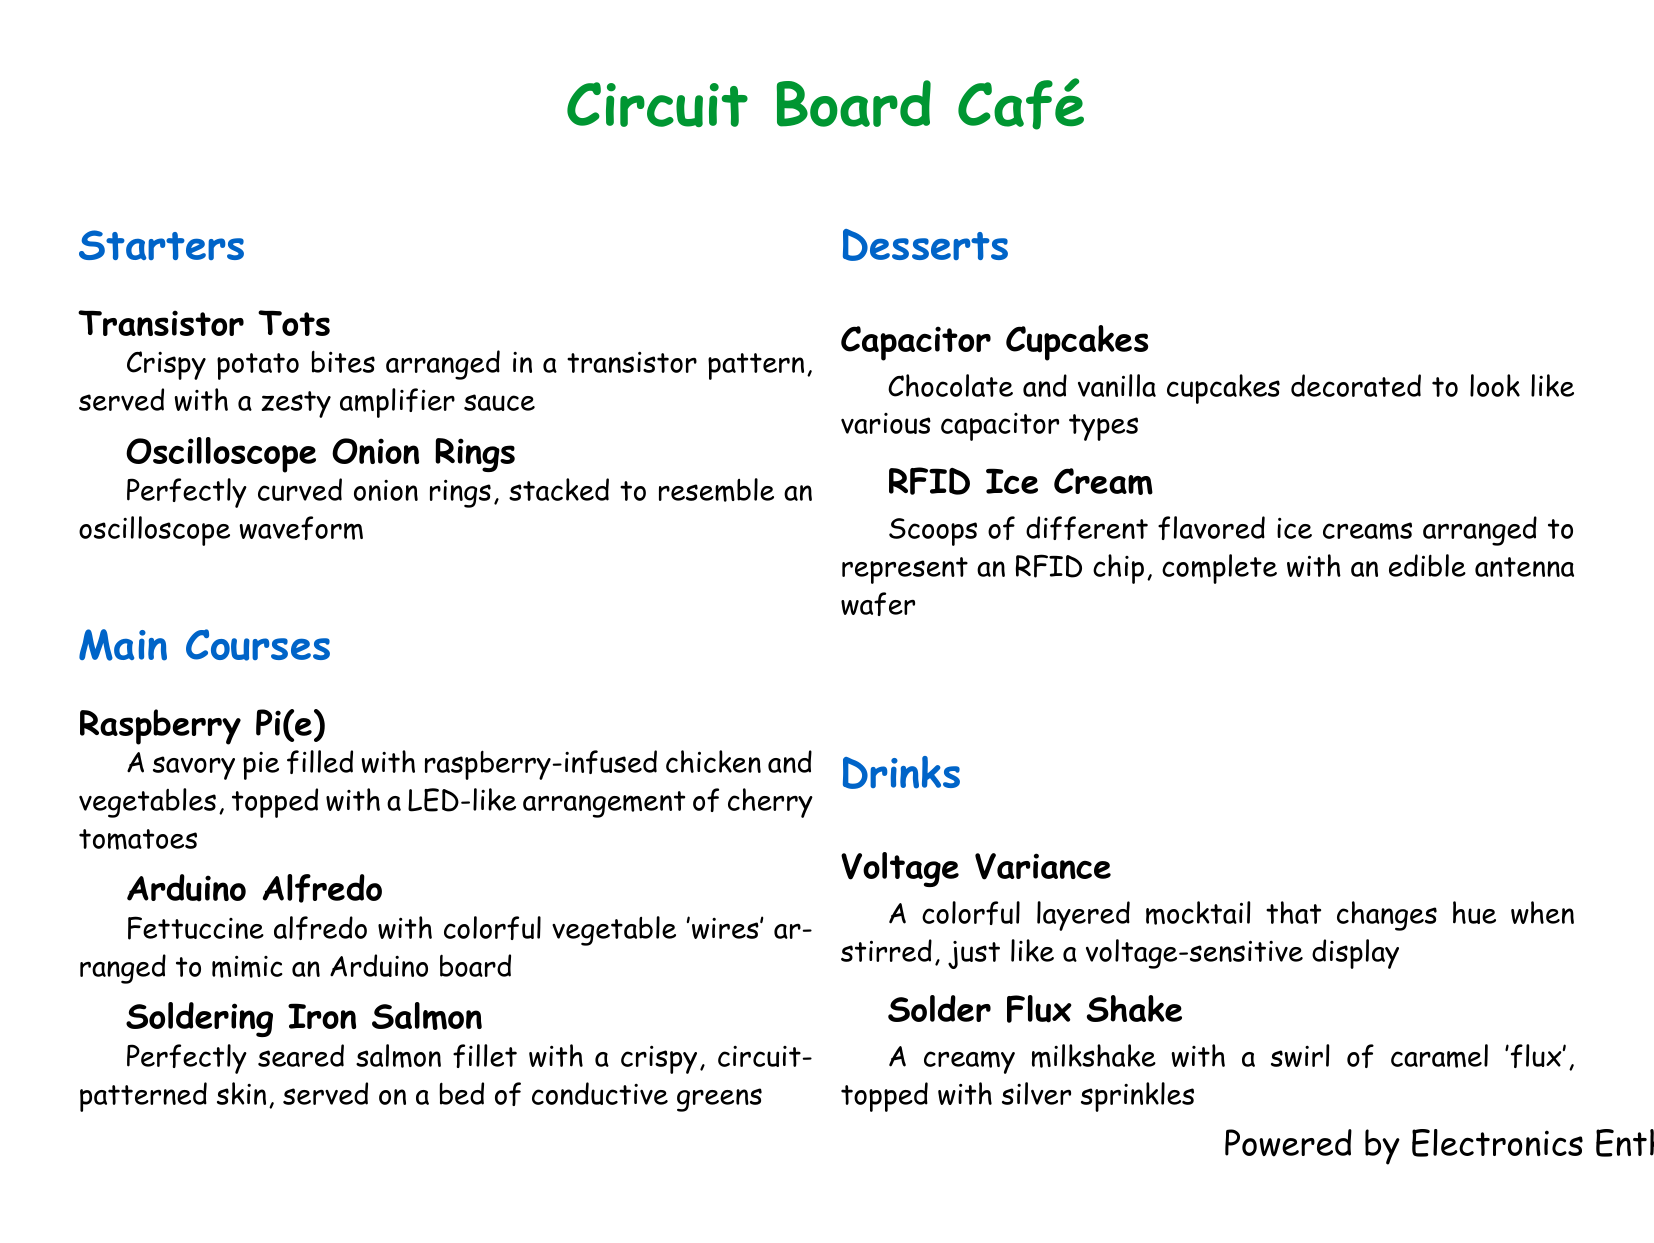What is the name of this café? The café is titled "Circuit Board Café," which reflects its science fair theme and electronics focus.
Answer: Circuit Board Café How many sections are in the menu? The menu contains four main sections: Starters, Main Courses, Desserts, and Drinks.
Answer: Four What is the main ingredient in Raspberry Pi(e)? The dish named Raspberry Pi(e) features raspberry-infused chicken and vegetables as its filling.
Answer: Raspberry-infused chicken and vegetables Which dessert resembles an RFID chip? The dessert that represents an RFID chip is the "RFID Ice Cream," which is artistically arranged to depict its design.
Answer: RFID Ice Cream What drink changes color when stirred? The drink that changes hue upon stirring is called "Voltage Variance," showcasing a dynamic visual effect.
Answer: Voltage Variance What type of sauce accompanies Transistor Tots? "Transistor Tots" are served with a zesty amplifier sauce, adding flavor to the dish.
Answer: Zesty amplifier sauce Which main course has a circuit-patterned skin? The main course with a circuit-patterned skin is the "Soldering Iron Salmon," emphasizing its unique presentation.
Answer: Soldering Iron Salmon How are the cupcakes in the dessert section styled? The "Capacitor Cupcakes" are decorated to resemble various capacitor types, creating a playful visual theme.
Answer: Various capacitor types What is the topping for the Solder Flux Shake? The topping for the "Solder Flux Shake" includes silver sprinkles, enhancing its aesthetic appeal.
Answer: Silver sprinkles What is the key characteristic of Arduino Alfredo? The "Arduino Alfredo" features colorful vegetable 'wires' arranged specifically to mimic an Arduino board design.
Answer: Colorful vegetable 'wires' 